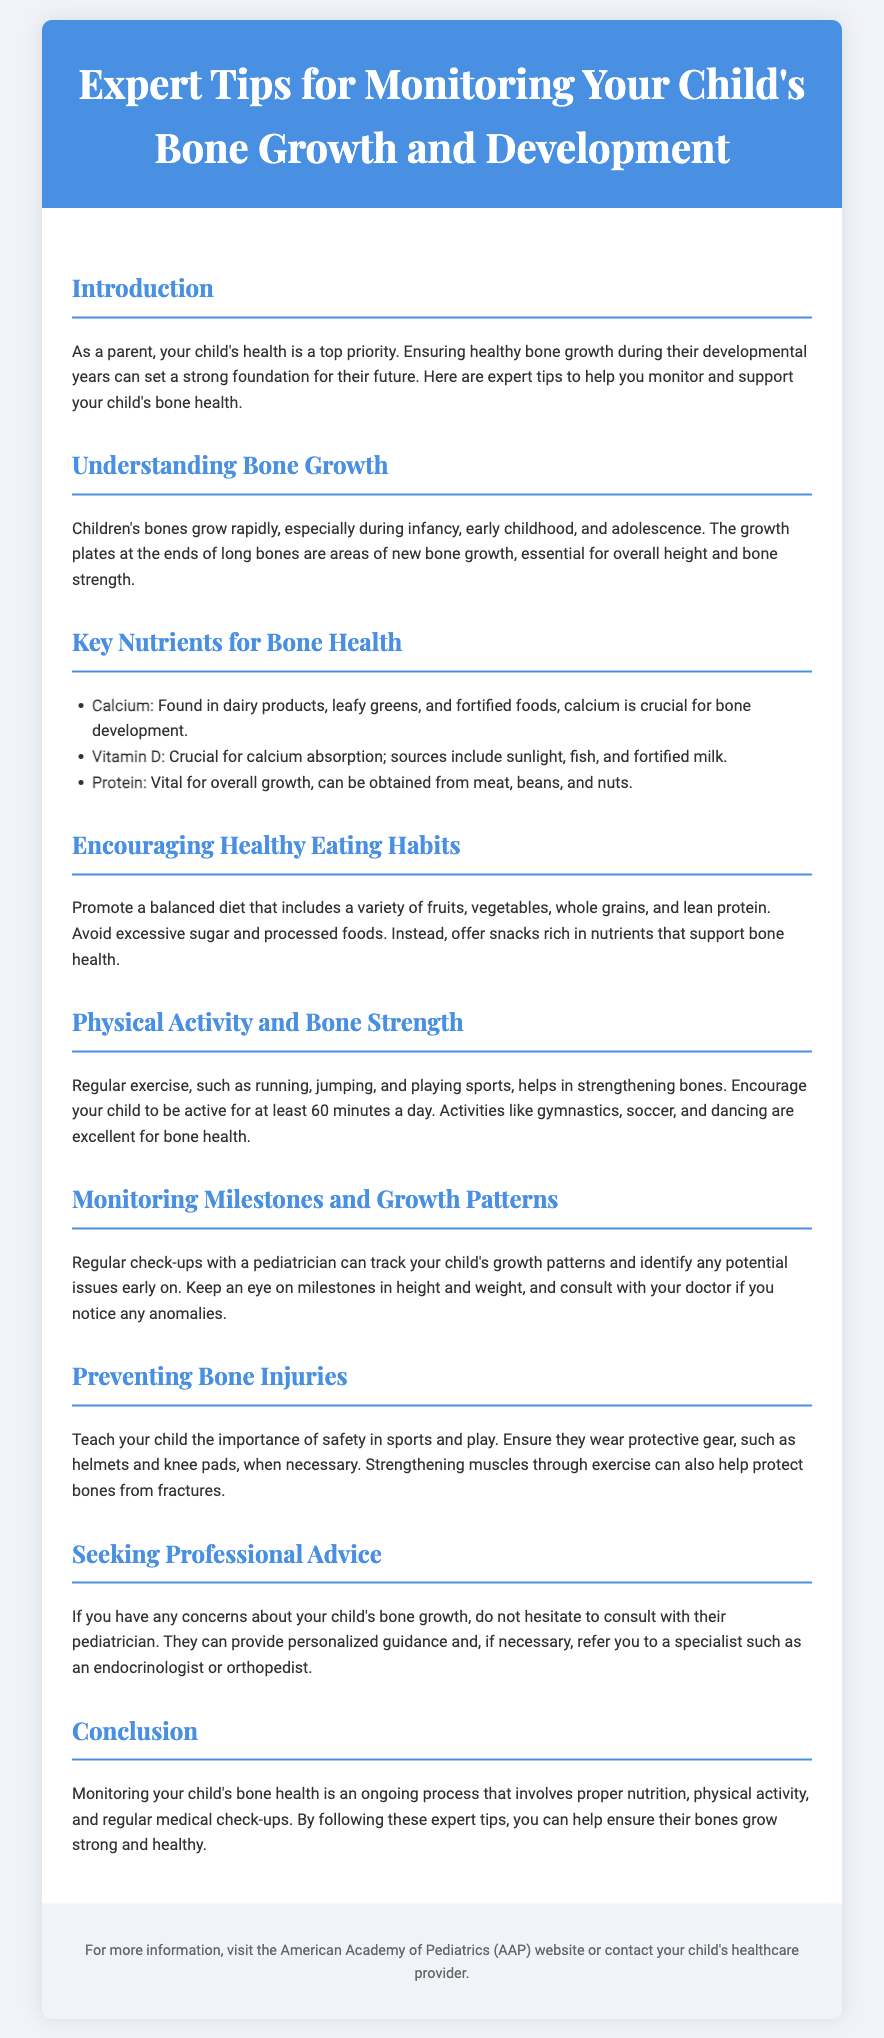What are the key nutrients for bone health? The document lists calcium, vitamin D, and protein as key nutrients for bone health.
Answer: calcium, vitamin D, protein What is the recommended daily exercise duration for children? The document states that children should be active for at least 60 minutes a day.
Answer: 60 minutes Which food group is emphasized for a balanced diet? The document underscores the importance of including a variety of fruits, vegetables, whole grains, and lean protein in a balanced diet.
Answer: fruits, vegetables, whole grains, lean protein What type of specialist might a pediatrician refer a parent to if concerns about bone growth arise? The document mentions an endocrinologist or orthopedist as potential specialists for concerns about bone growth.
Answer: endocrinologist, orthopedist What advice is given to prevent bone injuries during sports? The document advises teaching children the importance of safety in sports and wearing protective gear.
Answer: safety, protective gear 